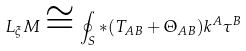<formula> <loc_0><loc_0><loc_500><loc_500>L _ { \xi } M \cong \oint _ { S } { * } ( T _ { A B } + \Theta _ { A B } ) k ^ { A } \tau ^ { B }</formula> 